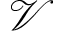<formula> <loc_0><loc_0><loc_500><loc_500>\mathcal { V }</formula> 